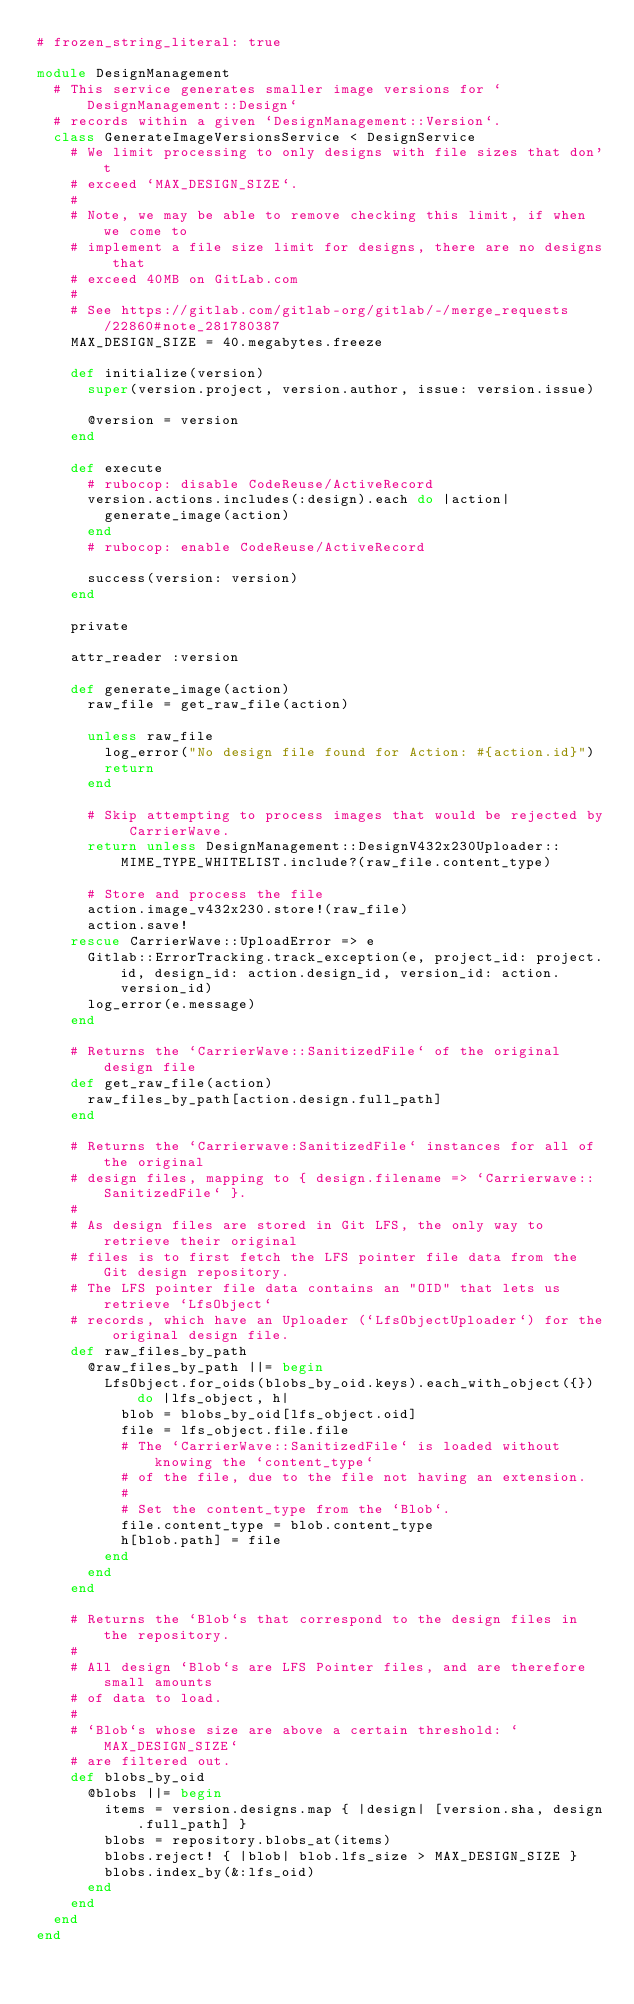<code> <loc_0><loc_0><loc_500><loc_500><_Ruby_># frozen_string_literal: true

module DesignManagement
  # This service generates smaller image versions for `DesignManagement::Design`
  # records within a given `DesignManagement::Version`.
  class GenerateImageVersionsService < DesignService
    # We limit processing to only designs with file sizes that don't
    # exceed `MAX_DESIGN_SIZE`.
    #
    # Note, we may be able to remove checking this limit, if when we come to
    # implement a file size limit for designs, there are no designs that
    # exceed 40MB on GitLab.com
    #
    # See https://gitlab.com/gitlab-org/gitlab/-/merge_requests/22860#note_281780387
    MAX_DESIGN_SIZE = 40.megabytes.freeze

    def initialize(version)
      super(version.project, version.author, issue: version.issue)

      @version = version
    end

    def execute
      # rubocop: disable CodeReuse/ActiveRecord
      version.actions.includes(:design).each do |action|
        generate_image(action)
      end
      # rubocop: enable CodeReuse/ActiveRecord

      success(version: version)
    end

    private

    attr_reader :version

    def generate_image(action)
      raw_file = get_raw_file(action)

      unless raw_file
        log_error("No design file found for Action: #{action.id}")
        return
      end

      # Skip attempting to process images that would be rejected by CarrierWave.
      return unless DesignManagement::DesignV432x230Uploader::MIME_TYPE_WHITELIST.include?(raw_file.content_type)

      # Store and process the file
      action.image_v432x230.store!(raw_file)
      action.save!
    rescue CarrierWave::UploadError => e
      Gitlab::ErrorTracking.track_exception(e, project_id: project.id, design_id: action.design_id, version_id: action.version_id)
      log_error(e.message)
    end

    # Returns the `CarrierWave::SanitizedFile` of the original design file
    def get_raw_file(action)
      raw_files_by_path[action.design.full_path]
    end

    # Returns the `Carrierwave:SanitizedFile` instances for all of the original
    # design files, mapping to { design.filename => `Carrierwave::SanitizedFile` }.
    #
    # As design files are stored in Git LFS, the only way to retrieve their original
    # files is to first fetch the LFS pointer file data from the Git design repository.
    # The LFS pointer file data contains an "OID" that lets us retrieve `LfsObject`
    # records, which have an Uploader (`LfsObjectUploader`) for the original design file.
    def raw_files_by_path
      @raw_files_by_path ||= begin
        LfsObject.for_oids(blobs_by_oid.keys).each_with_object({}) do |lfs_object, h|
          blob = blobs_by_oid[lfs_object.oid]
          file = lfs_object.file.file
          # The `CarrierWave::SanitizedFile` is loaded without knowing the `content_type`
          # of the file, due to the file not having an extension.
          #
          # Set the content_type from the `Blob`.
          file.content_type = blob.content_type
          h[blob.path] = file
        end
      end
    end

    # Returns the `Blob`s that correspond to the design files in the repository.
    #
    # All design `Blob`s are LFS Pointer files, and are therefore small amounts
    # of data to load.
    #
    # `Blob`s whose size are above a certain threshold: `MAX_DESIGN_SIZE`
    # are filtered out.
    def blobs_by_oid
      @blobs ||= begin
        items = version.designs.map { |design| [version.sha, design.full_path] }
        blobs = repository.blobs_at(items)
        blobs.reject! { |blob| blob.lfs_size > MAX_DESIGN_SIZE }
        blobs.index_by(&:lfs_oid)
      end
    end
  end
end
</code> 